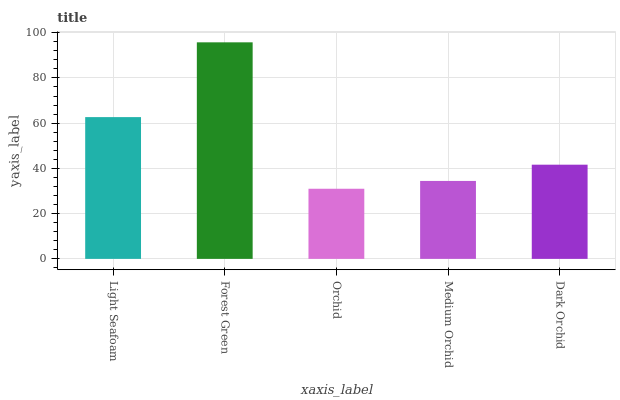Is Orchid the minimum?
Answer yes or no. Yes. Is Forest Green the maximum?
Answer yes or no. Yes. Is Forest Green the minimum?
Answer yes or no. No. Is Orchid the maximum?
Answer yes or no. No. Is Forest Green greater than Orchid?
Answer yes or no. Yes. Is Orchid less than Forest Green?
Answer yes or no. Yes. Is Orchid greater than Forest Green?
Answer yes or no. No. Is Forest Green less than Orchid?
Answer yes or no. No. Is Dark Orchid the high median?
Answer yes or no. Yes. Is Dark Orchid the low median?
Answer yes or no. Yes. Is Light Seafoam the high median?
Answer yes or no. No. Is Light Seafoam the low median?
Answer yes or no. No. 